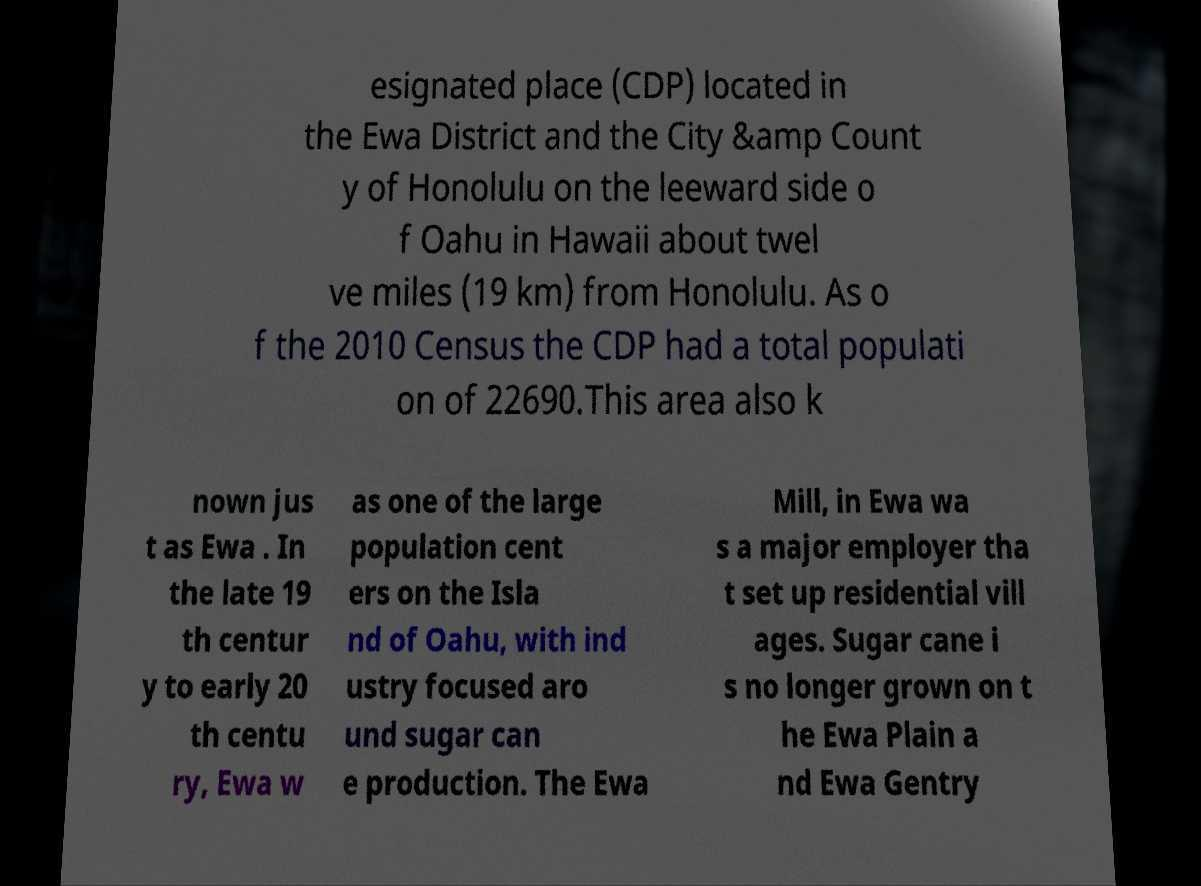For documentation purposes, I need the text within this image transcribed. Could you provide that? esignated place (CDP) located in the Ewa District and the City &amp Count y of Honolulu on the leeward side o f Oahu in Hawaii about twel ve miles (19 km) from Honolulu. As o f the 2010 Census the CDP had a total populati on of 22690.This area also k nown jus t as Ewa . In the late 19 th centur y to early 20 th centu ry, Ewa w as one of the large population cent ers on the Isla nd of Oahu, with ind ustry focused aro und sugar can e production. The Ewa Mill, in Ewa wa s a major employer tha t set up residential vill ages. Sugar cane i s no longer grown on t he Ewa Plain a nd Ewa Gentry 